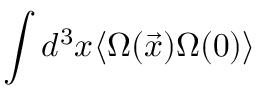<formula> <loc_0><loc_0><loc_500><loc_500>\int d ^ { 3 } x \langle \Omega ( \vec { x } ) \Omega ( 0 ) \rangle</formula> 